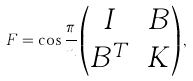Convert formula to latex. <formula><loc_0><loc_0><loc_500><loc_500>F = \cos \frac { \pi } { n } \begin{pmatrix} I & B \\ B ^ { T } & K \end{pmatrix} ,</formula> 